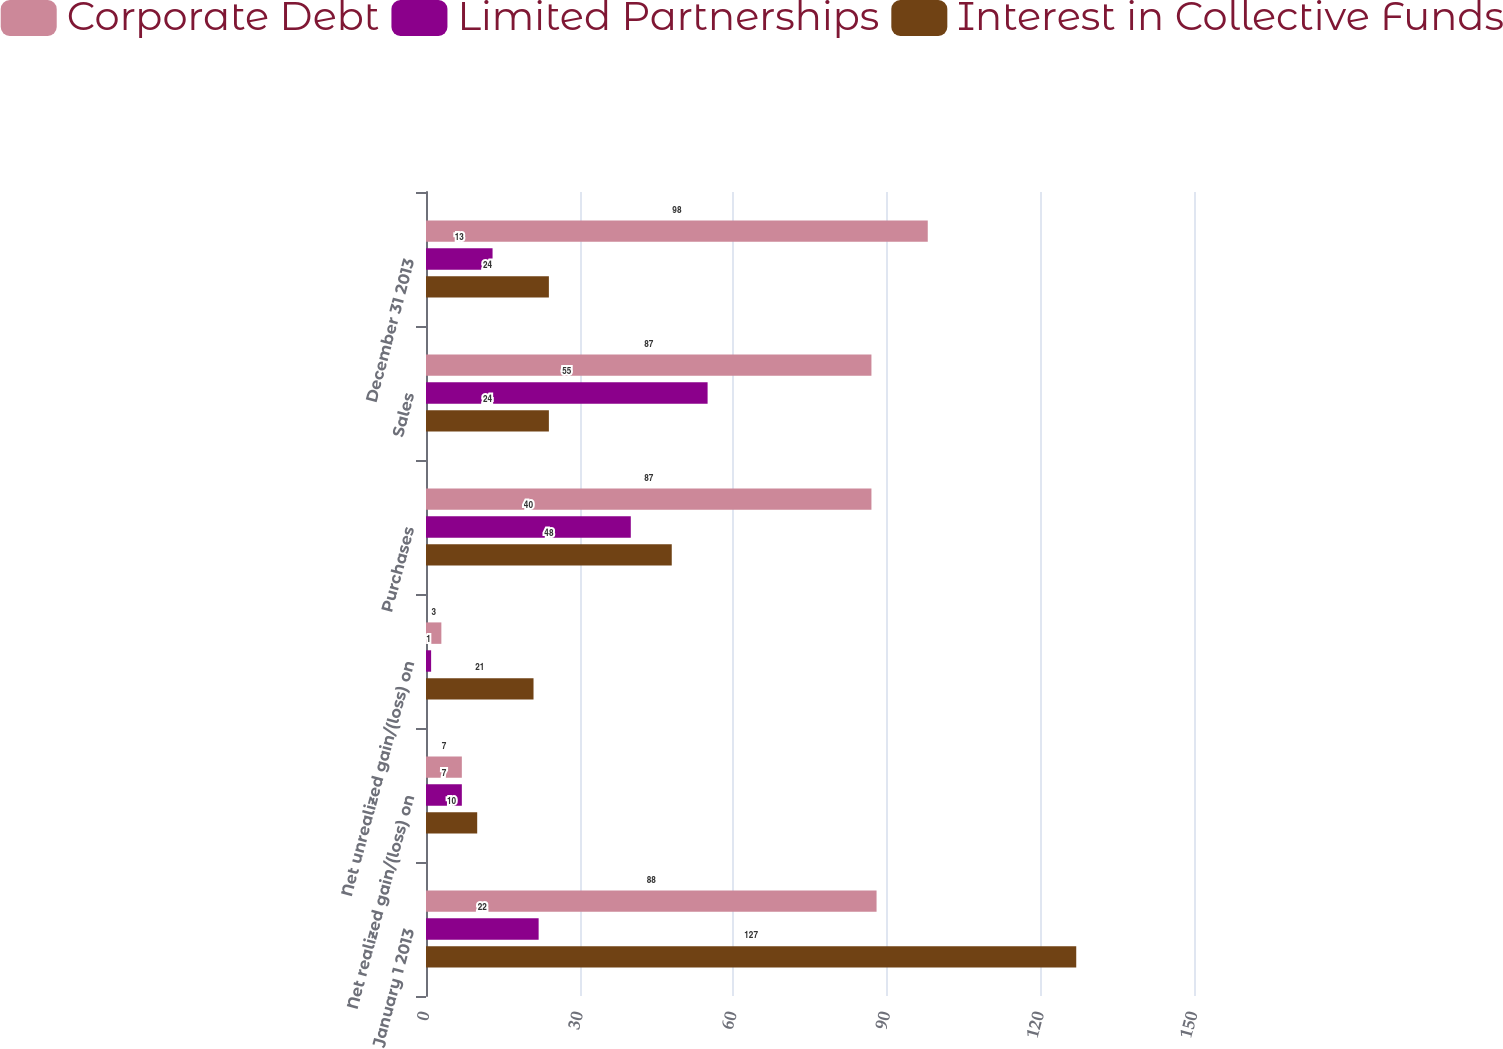Convert chart. <chart><loc_0><loc_0><loc_500><loc_500><stacked_bar_chart><ecel><fcel>January 1 2013<fcel>Net realized gain/(loss) on<fcel>Net unrealized gain/(loss) on<fcel>Purchases<fcel>Sales<fcel>December 31 2013<nl><fcel>Corporate Debt<fcel>88<fcel>7<fcel>3<fcel>87<fcel>87<fcel>98<nl><fcel>Limited Partnerships<fcel>22<fcel>7<fcel>1<fcel>40<fcel>55<fcel>13<nl><fcel>Interest in Collective Funds<fcel>127<fcel>10<fcel>21<fcel>48<fcel>24<fcel>24<nl></chart> 